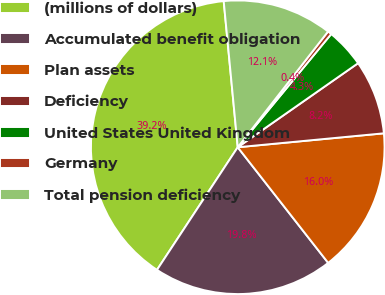Convert chart to OTSL. <chart><loc_0><loc_0><loc_500><loc_500><pie_chart><fcel>(millions of dollars)<fcel>Accumulated benefit obligation<fcel>Plan assets<fcel>Deficiency<fcel>United States United Kingdom<fcel>Germany<fcel>Total pension deficiency<nl><fcel>39.21%<fcel>19.83%<fcel>15.95%<fcel>8.19%<fcel>4.31%<fcel>0.44%<fcel>12.07%<nl></chart> 